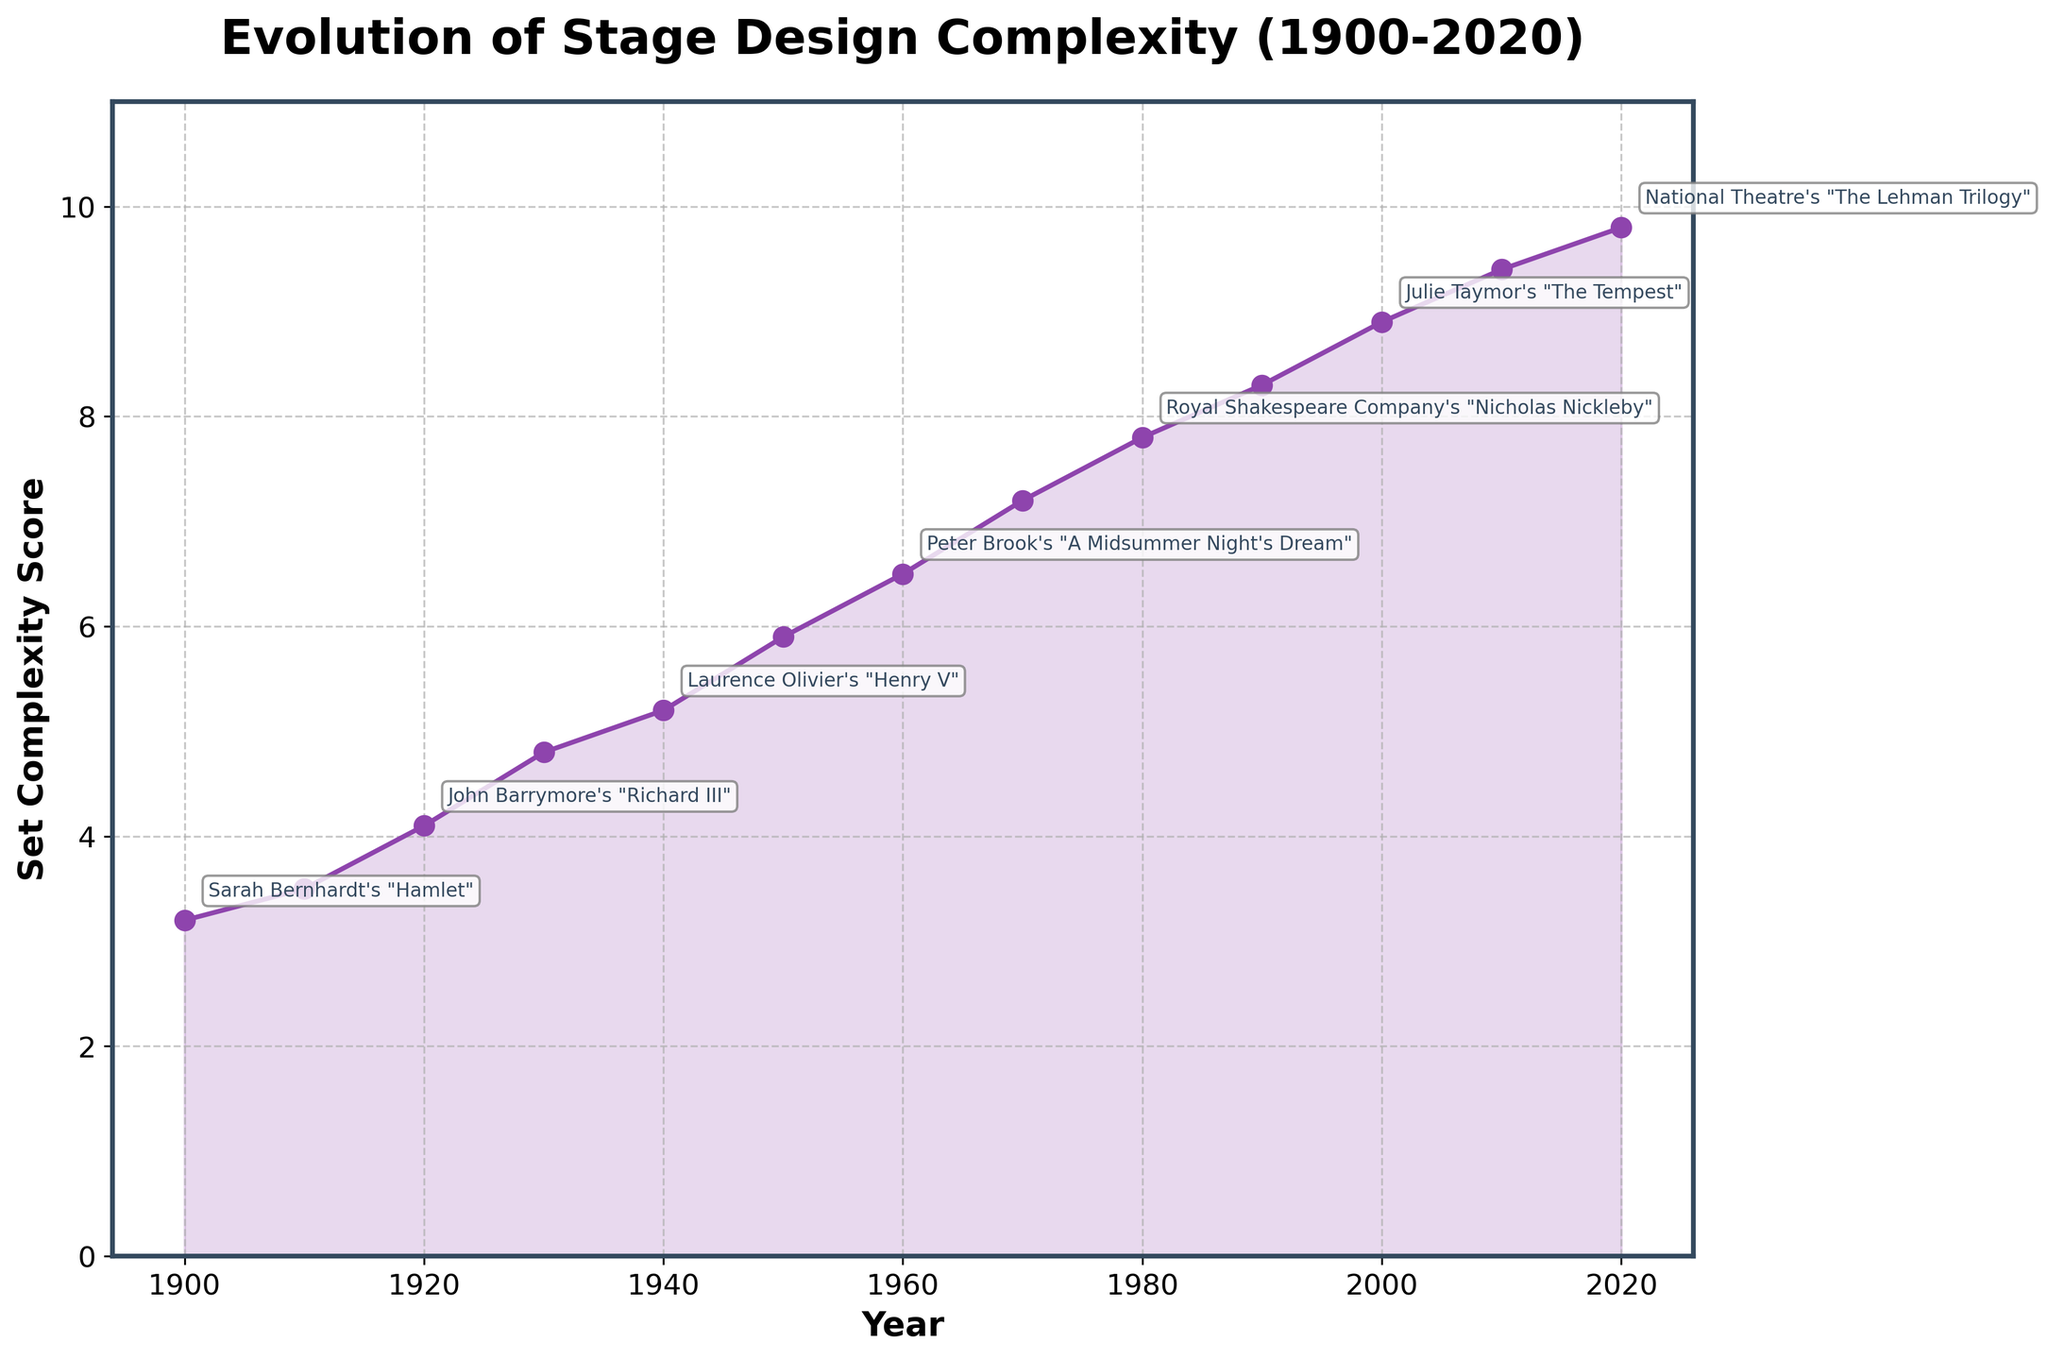What's the Set Complexity Score in 1930? Locate the year 1930 on the x-axis, find the corresponding point on the line, and read the y-axis value, which is around 4.8.
Answer: 4.8 How many notable productions are labeled on the figure? Count the annotations visible on the figure. Every other point is annotated.
Answer: 7 Which year shows the highest recorded Set Complexity Score and what is the notable production? Notice the highest point on the chart and identify the corresponding x-axis year and its annotation.
Answer: 2020, "The Lehman Trilogy" Between which years did the Set Complexity Score experience the largest increase? Identify the steepest segment of the line connecting the data points. The steepest increase appears between 1930 and 1940.
Answer: 1930-1940 What is the visual trend in the Set Complexity Score from 1900 to 2020? Observe the overall direction of the line chart from 1900 to 2020, noting consistent upward slopes without any significant drops.
Answer: Increasing What is the difference in Set Complexity Score between 1960 and 1980? Locate the points for years 1960 (6.5) and 1980 (7.8), and subtract the values: 7.8 - 6.5 = 1.3.
Answer: 1.3 Which period shows a consistent linear increase in Set Complexity Score, and how much is this increase? Identifying a period with almost uniform increments in the line graph helps. 1970 to 2010 appears linear. For 1970 (7.2) to 2010 (9.4), the increase is 9.4 - 7.2 = 2.2.
Answer: 1970-2010, 2.2 How much did the Set Complexity Score change between Maurice Evans' notable productions in 1930 and 1950? Identify the scores for 1930's Richard II (4.8) and 1950's Macbeth (5.9), and calculate the difference: 5.9 - 4.8 = 1.1.
Answer: 1.1 Which decade experienced the smallest increase in Set Complexity Score? Examine each decadal segment on the chart and compare the differences. The smallest increase appears between 2010 (9.4) and 2020 (9.8), which is 0.4.
Answer: 2010-2020 What is the average Set Complexity Score for the notable productions between 1900 to 1950 inclusive? Adding the Set Complexity Scores from 1900 (3.2), 1910 (3.5), 1920 (4.1), 1930 (4.8), 1940 (5.2), and 1950 (5.9) equals 26.7. Dividing by 6, the years count gives 26.7 / 6 ≈ 4.45.
Answer: 4.45 